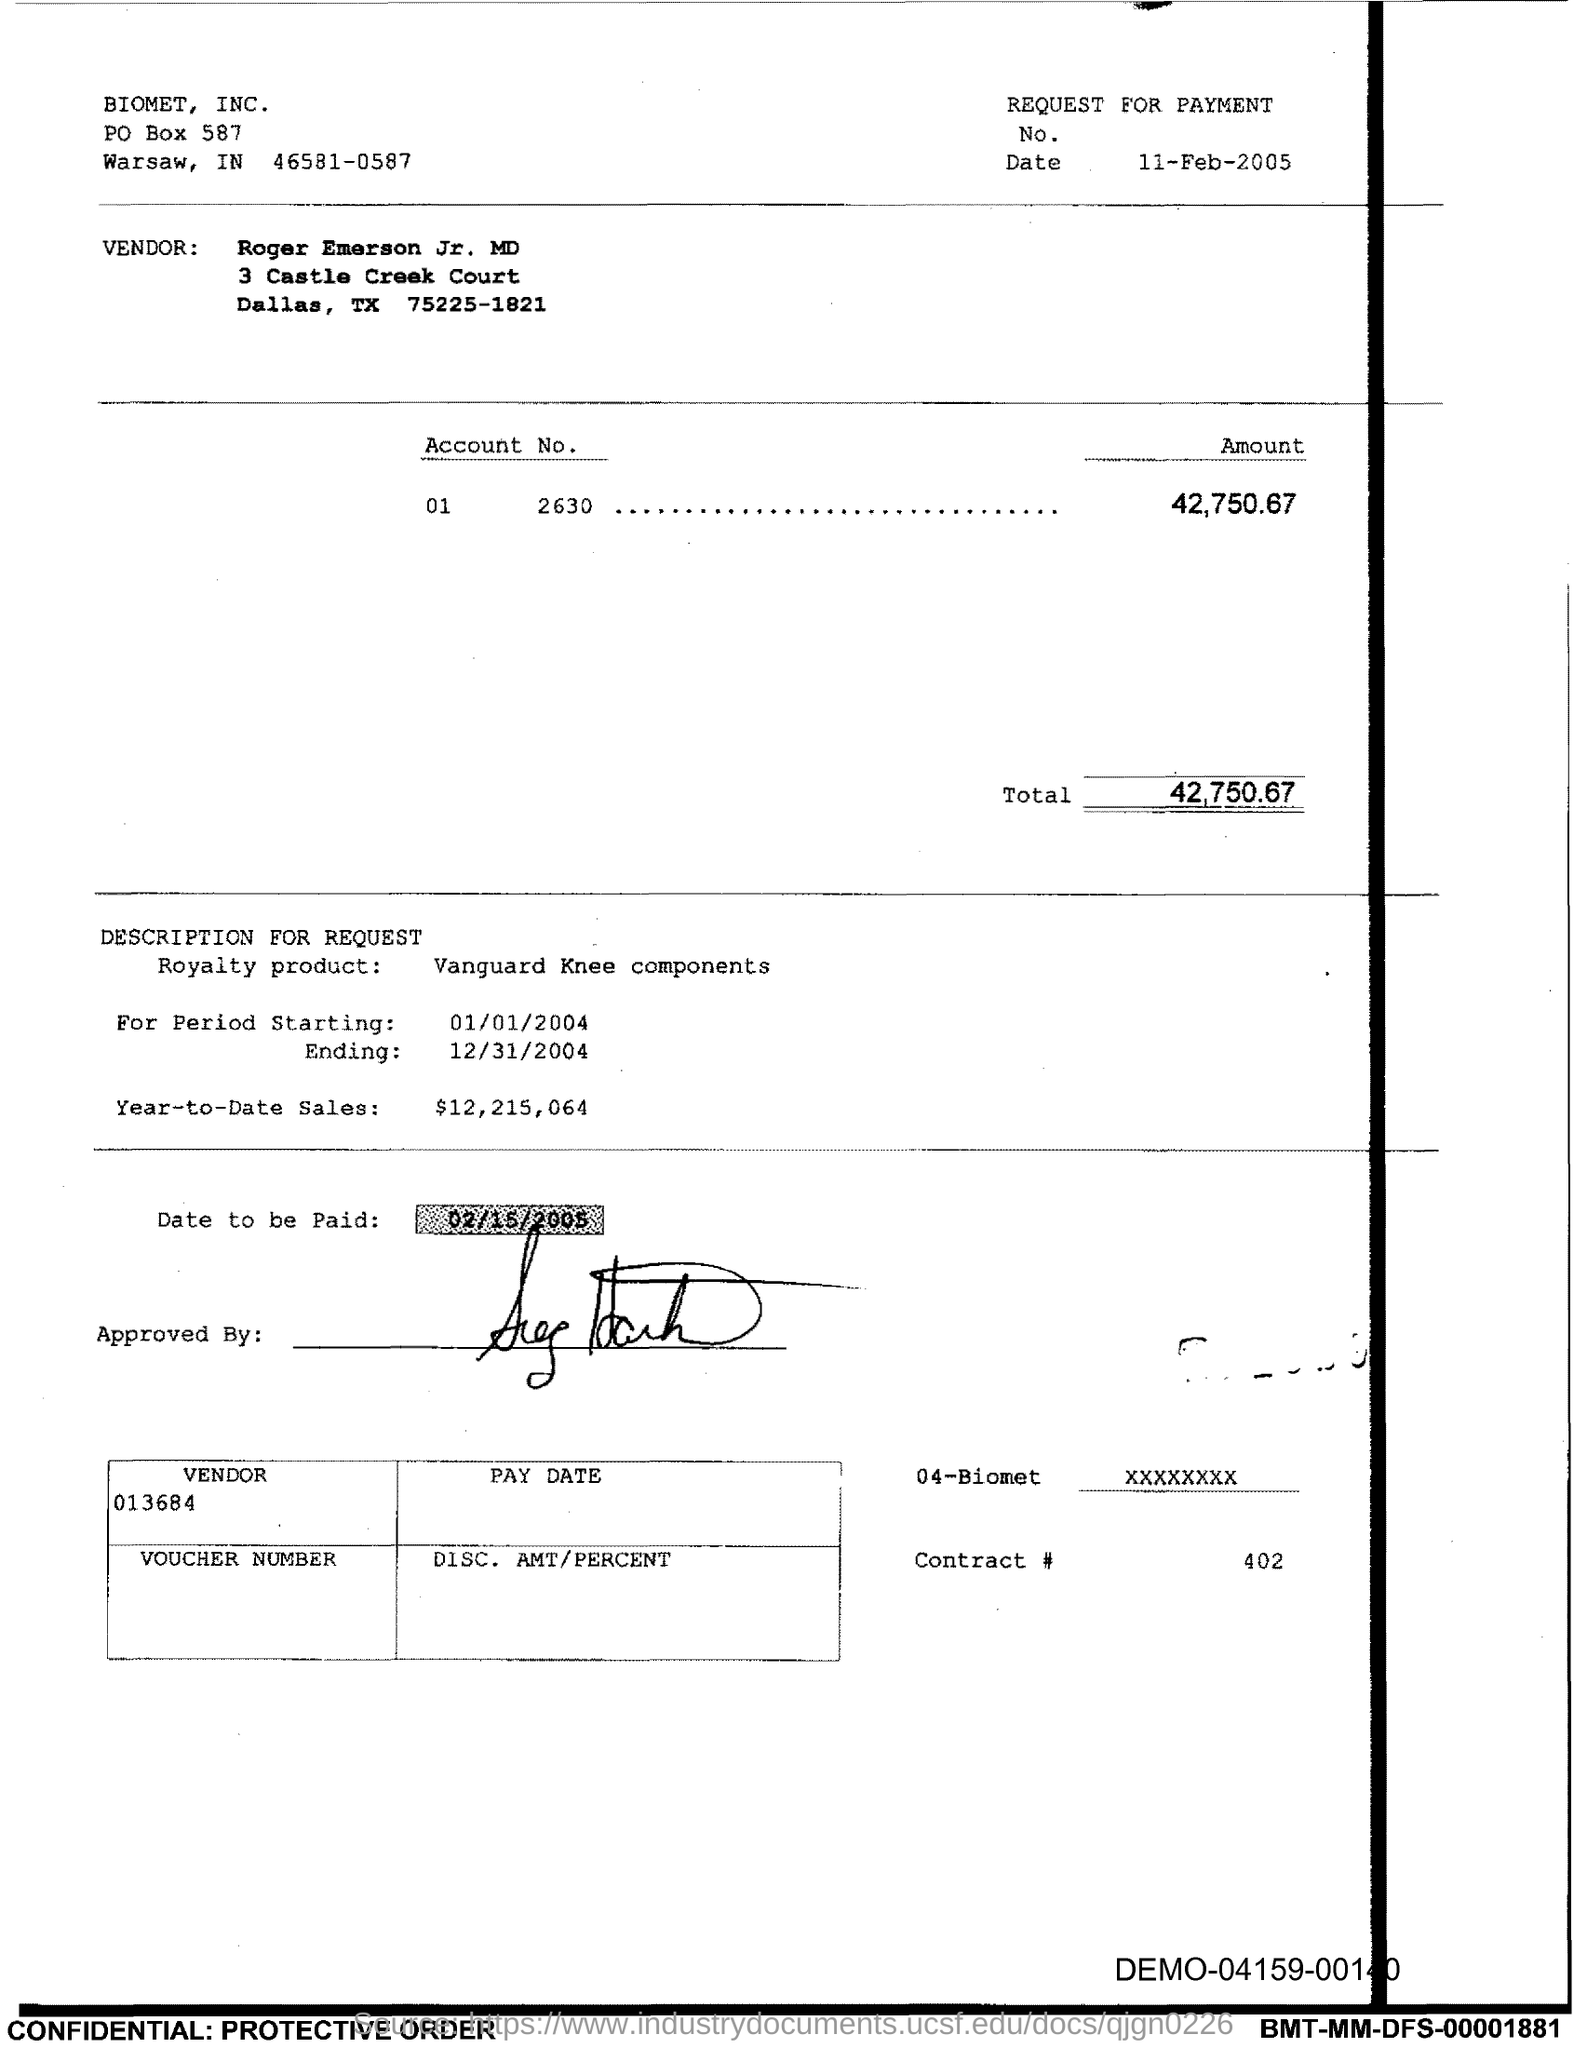Highlight a few significant elements in this photo. The payment due date mentioned in this voucher is February 15, 2005. The voucher indicates an amount of 42,750.67. 